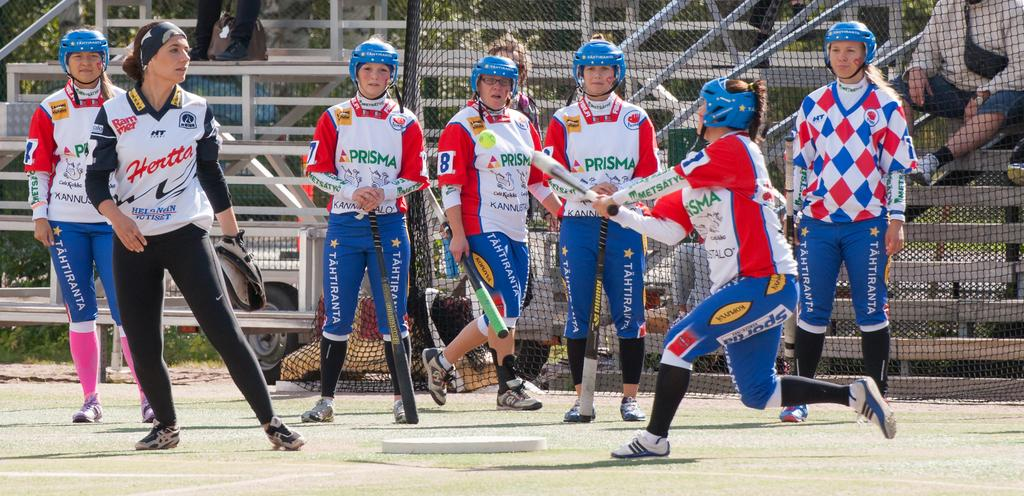<image>
Share a concise interpretation of the image provided. A team of softball players advertising Prisma on their jerseys. 